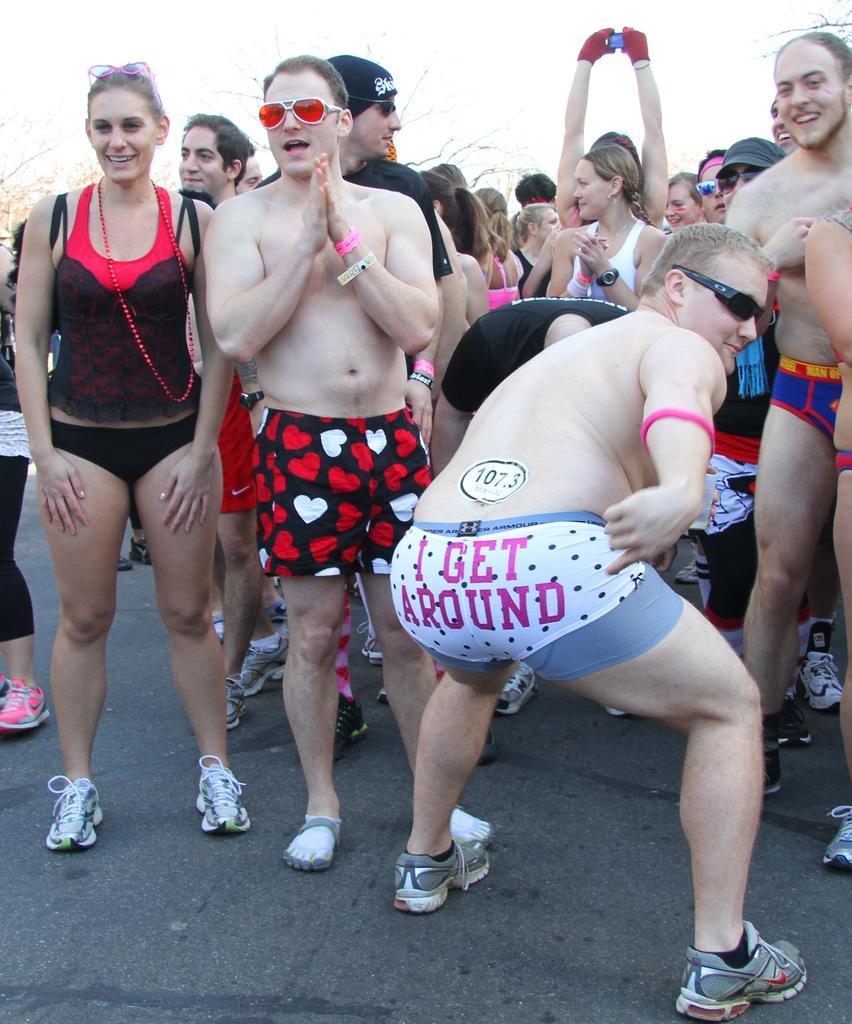Describe this image in one or two sentences. In this image, we can see people wearing clothes. At the top of the image, we can see the sky. 